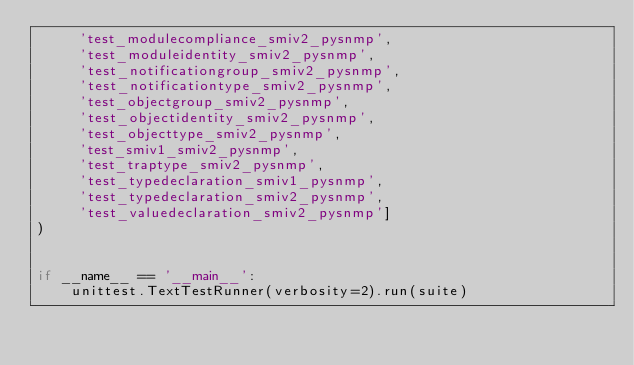<code> <loc_0><loc_0><loc_500><loc_500><_Python_>     'test_modulecompliance_smiv2_pysnmp',
     'test_moduleidentity_smiv2_pysnmp',
     'test_notificationgroup_smiv2_pysnmp',
     'test_notificationtype_smiv2_pysnmp',
     'test_objectgroup_smiv2_pysnmp',
     'test_objectidentity_smiv2_pysnmp',
     'test_objecttype_smiv2_pysnmp',
     'test_smiv1_smiv2_pysnmp',
     'test_traptype_smiv2_pysnmp',
     'test_typedeclaration_smiv1_pysnmp',
     'test_typedeclaration_smiv2_pysnmp',
     'test_valuedeclaration_smiv2_pysnmp']
)


if __name__ == '__main__':
    unittest.TextTestRunner(verbosity=2).run(suite)
</code> 